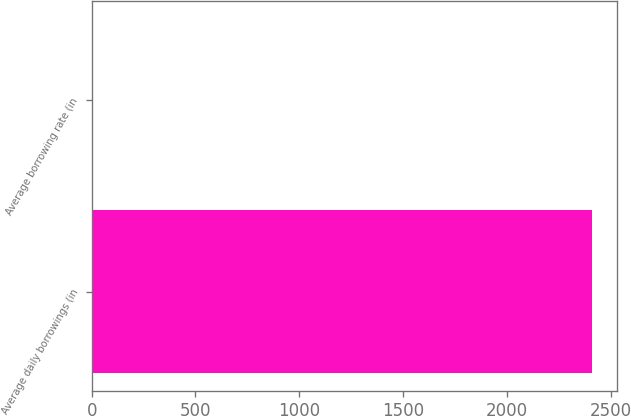<chart> <loc_0><loc_0><loc_500><loc_500><bar_chart><fcel>Average daily borrowings (in<fcel>Average borrowing rate (in<nl><fcel>2408<fcel>6.2<nl></chart> 